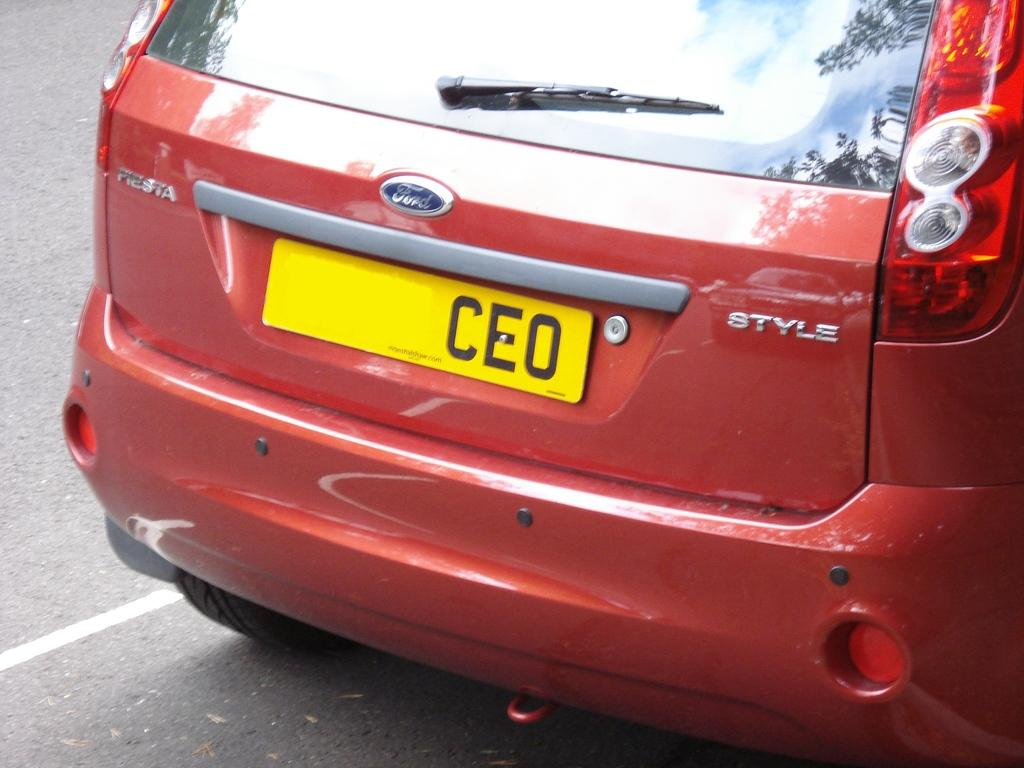<image>
Relay a brief, clear account of the picture shown. back or baggage of the red Ford car, stylr mode, with licence plate with the words CEO 